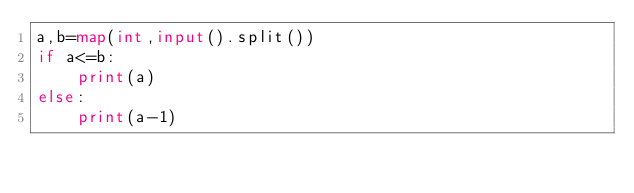Convert code to text. <code><loc_0><loc_0><loc_500><loc_500><_Python_>a,b=map(int,input().split())
if a<=b:
    print(a)
else:
    print(a-1)</code> 